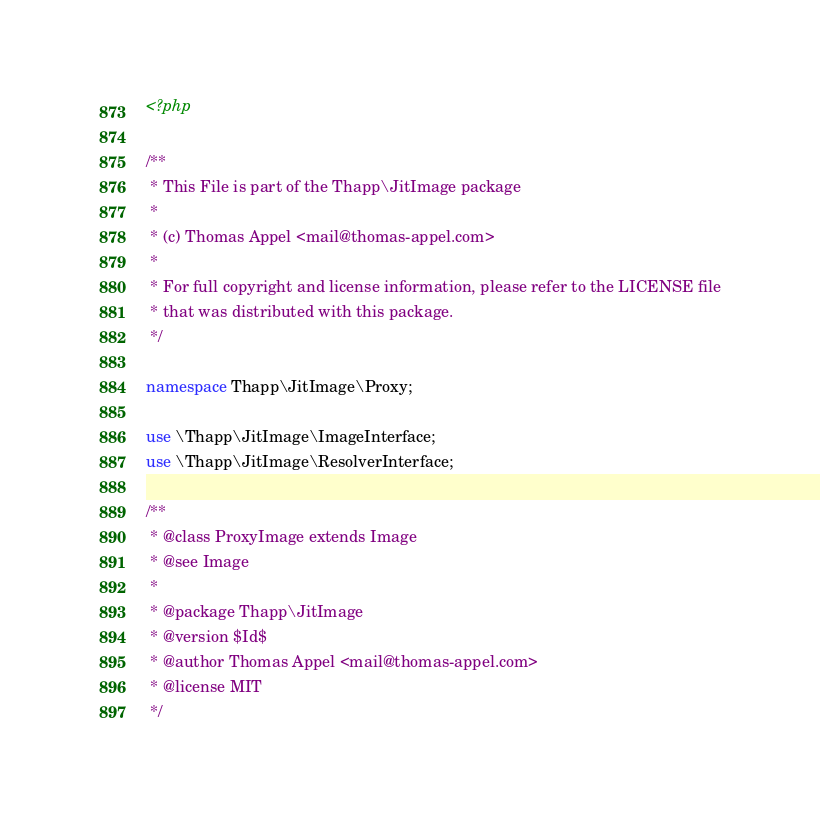Convert code to text. <code><loc_0><loc_0><loc_500><loc_500><_PHP_><?php

/**
 * This File is part of the Thapp\JitImage package
 *
 * (c) Thomas Appel <mail@thomas-appel.com>
 *
 * For full copyright and license information, please refer to the LICENSE file
 * that was distributed with this package.
 */

namespace Thapp\JitImage\Proxy;

use \Thapp\JitImage\ImageInterface;
use \Thapp\JitImage\ResolverInterface;

/**
 * @class ProxyImage extends Image
 * @see Image
 *
 * @package Thapp\JitImage
 * @version $Id$
 * @author Thomas Appel <mail@thomas-appel.com>
 * @license MIT
 */</code> 